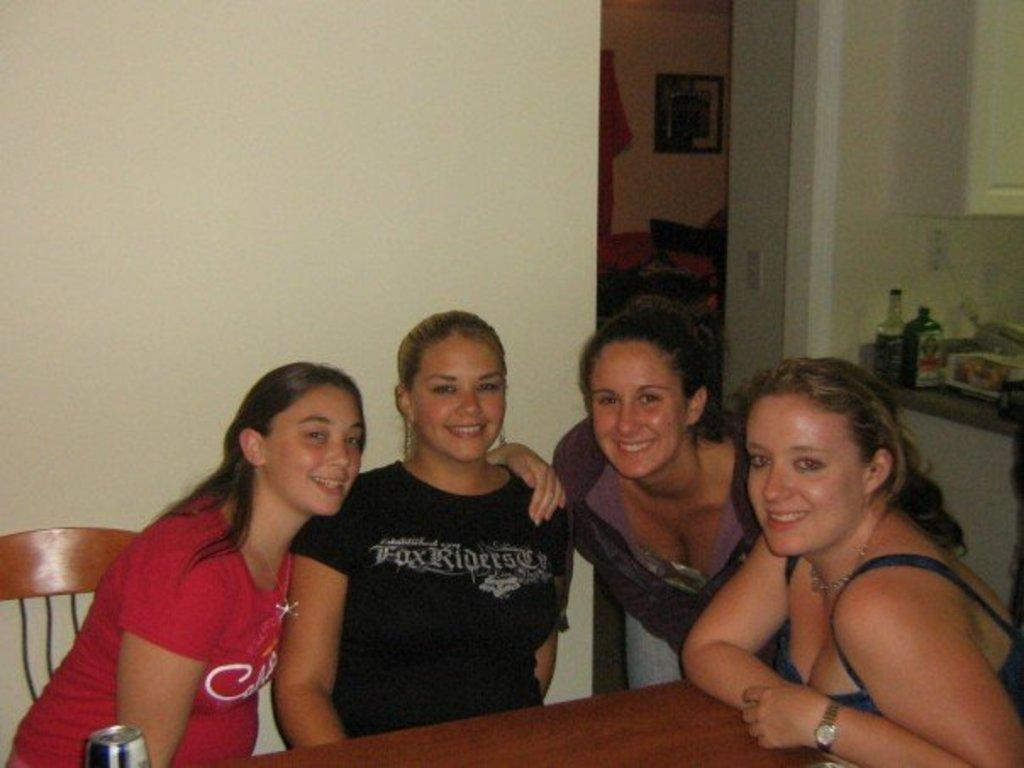What are the women in the image doing? The women in the image are sitting on chairs. What can be seen in the background of the image? In the background of the image, there are walls, wall hangings, beverage bottles, a switchboard, a cupboard, and books. Can you describe the objects on the walls in the background? The wall hangings are present on the walls in the background of the image. What type of advertisement can be seen on the cupboard in the image? There is no advertisement present on the cupboard in the image. 